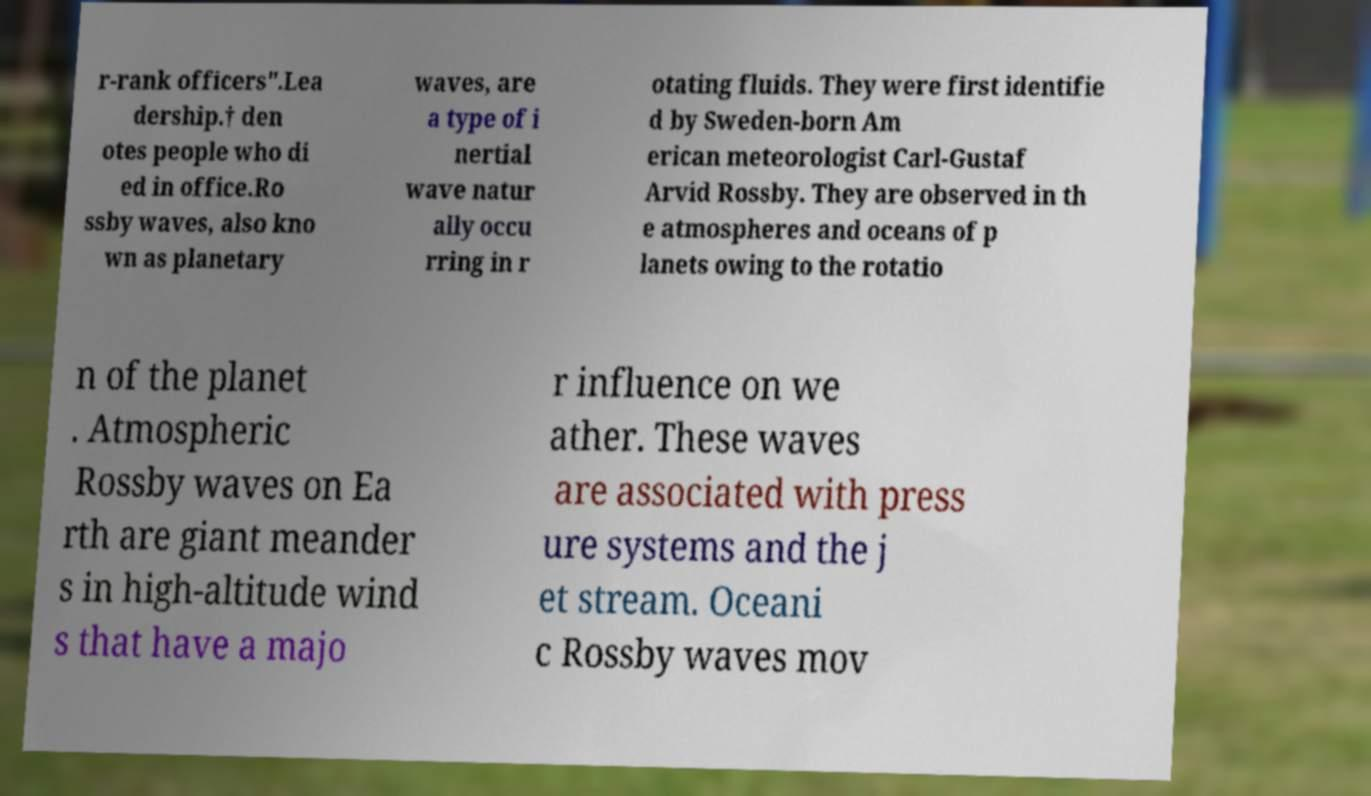Can you accurately transcribe the text from the provided image for me? r-rank officers".Lea dership.† den otes people who di ed in office.Ro ssby waves, also kno wn as planetary waves, are a type of i nertial wave natur ally occu rring in r otating fluids. They were first identifie d by Sweden-born Am erican meteorologist Carl-Gustaf Arvid Rossby. They are observed in th e atmospheres and oceans of p lanets owing to the rotatio n of the planet . Atmospheric Rossby waves on Ea rth are giant meander s in high-altitude wind s that have a majo r influence on we ather. These waves are associated with press ure systems and the j et stream. Oceani c Rossby waves mov 